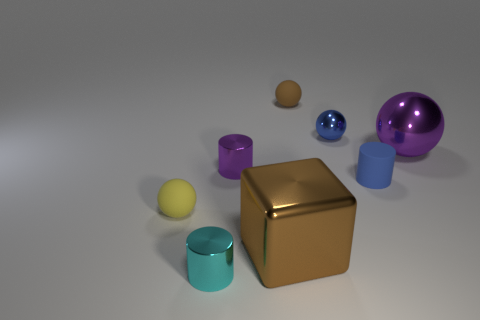What can you infer about the material of these objects? Based on their appearance, especially the way they reflect light, all these objects likely represent metallic materials which give them a certain luster and reflectiveness. 